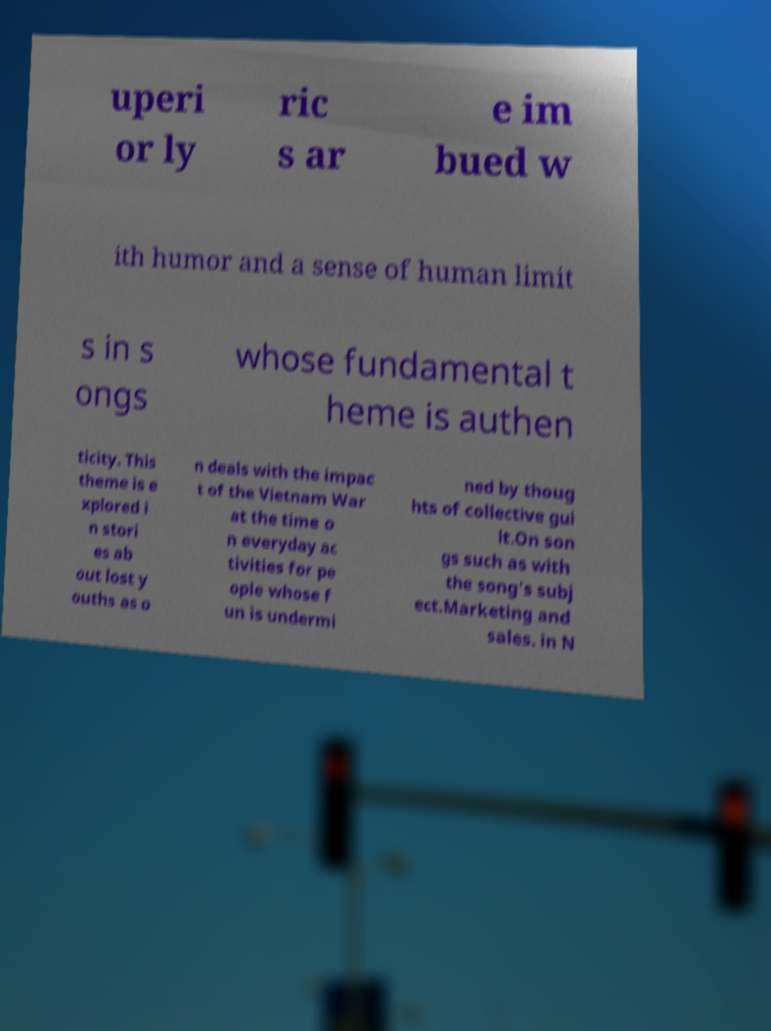Could you assist in decoding the text presented in this image and type it out clearly? uperi or ly ric s ar e im bued w ith humor and a sense of human limit s in s ongs whose fundamental t heme is authen ticity. This theme is e xplored i n stori es ab out lost y ouths as o n deals with the impac t of the Vietnam War at the time o n everyday ac tivities for pe ople whose f un is undermi ned by thoug hts of collective gui lt.On son gs such as with the song's subj ect.Marketing and sales. in N 